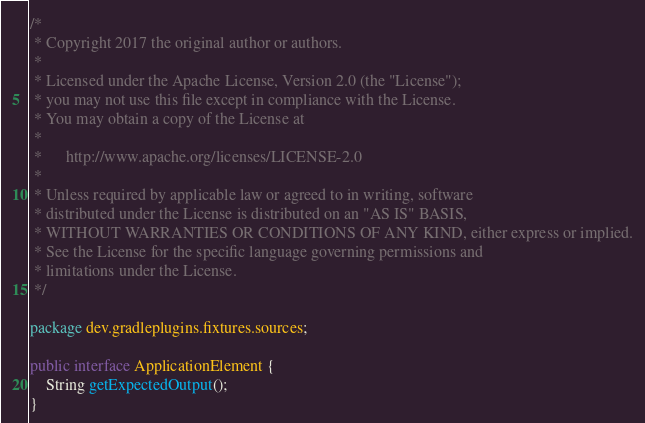<code> <loc_0><loc_0><loc_500><loc_500><_Java_>/*
 * Copyright 2017 the original author or authors.
 *
 * Licensed under the Apache License, Version 2.0 (the "License");
 * you may not use this file except in compliance with the License.
 * You may obtain a copy of the License at
 *
 *      http://www.apache.org/licenses/LICENSE-2.0
 *
 * Unless required by applicable law or agreed to in writing, software
 * distributed under the License is distributed on an "AS IS" BASIS,
 * WITHOUT WARRANTIES OR CONDITIONS OF ANY KIND, either express or implied.
 * See the License for the specific language governing permissions and
 * limitations under the License.
 */

package dev.gradleplugins.fixtures.sources;

public interface ApplicationElement {
    String getExpectedOutput();
}
</code> 